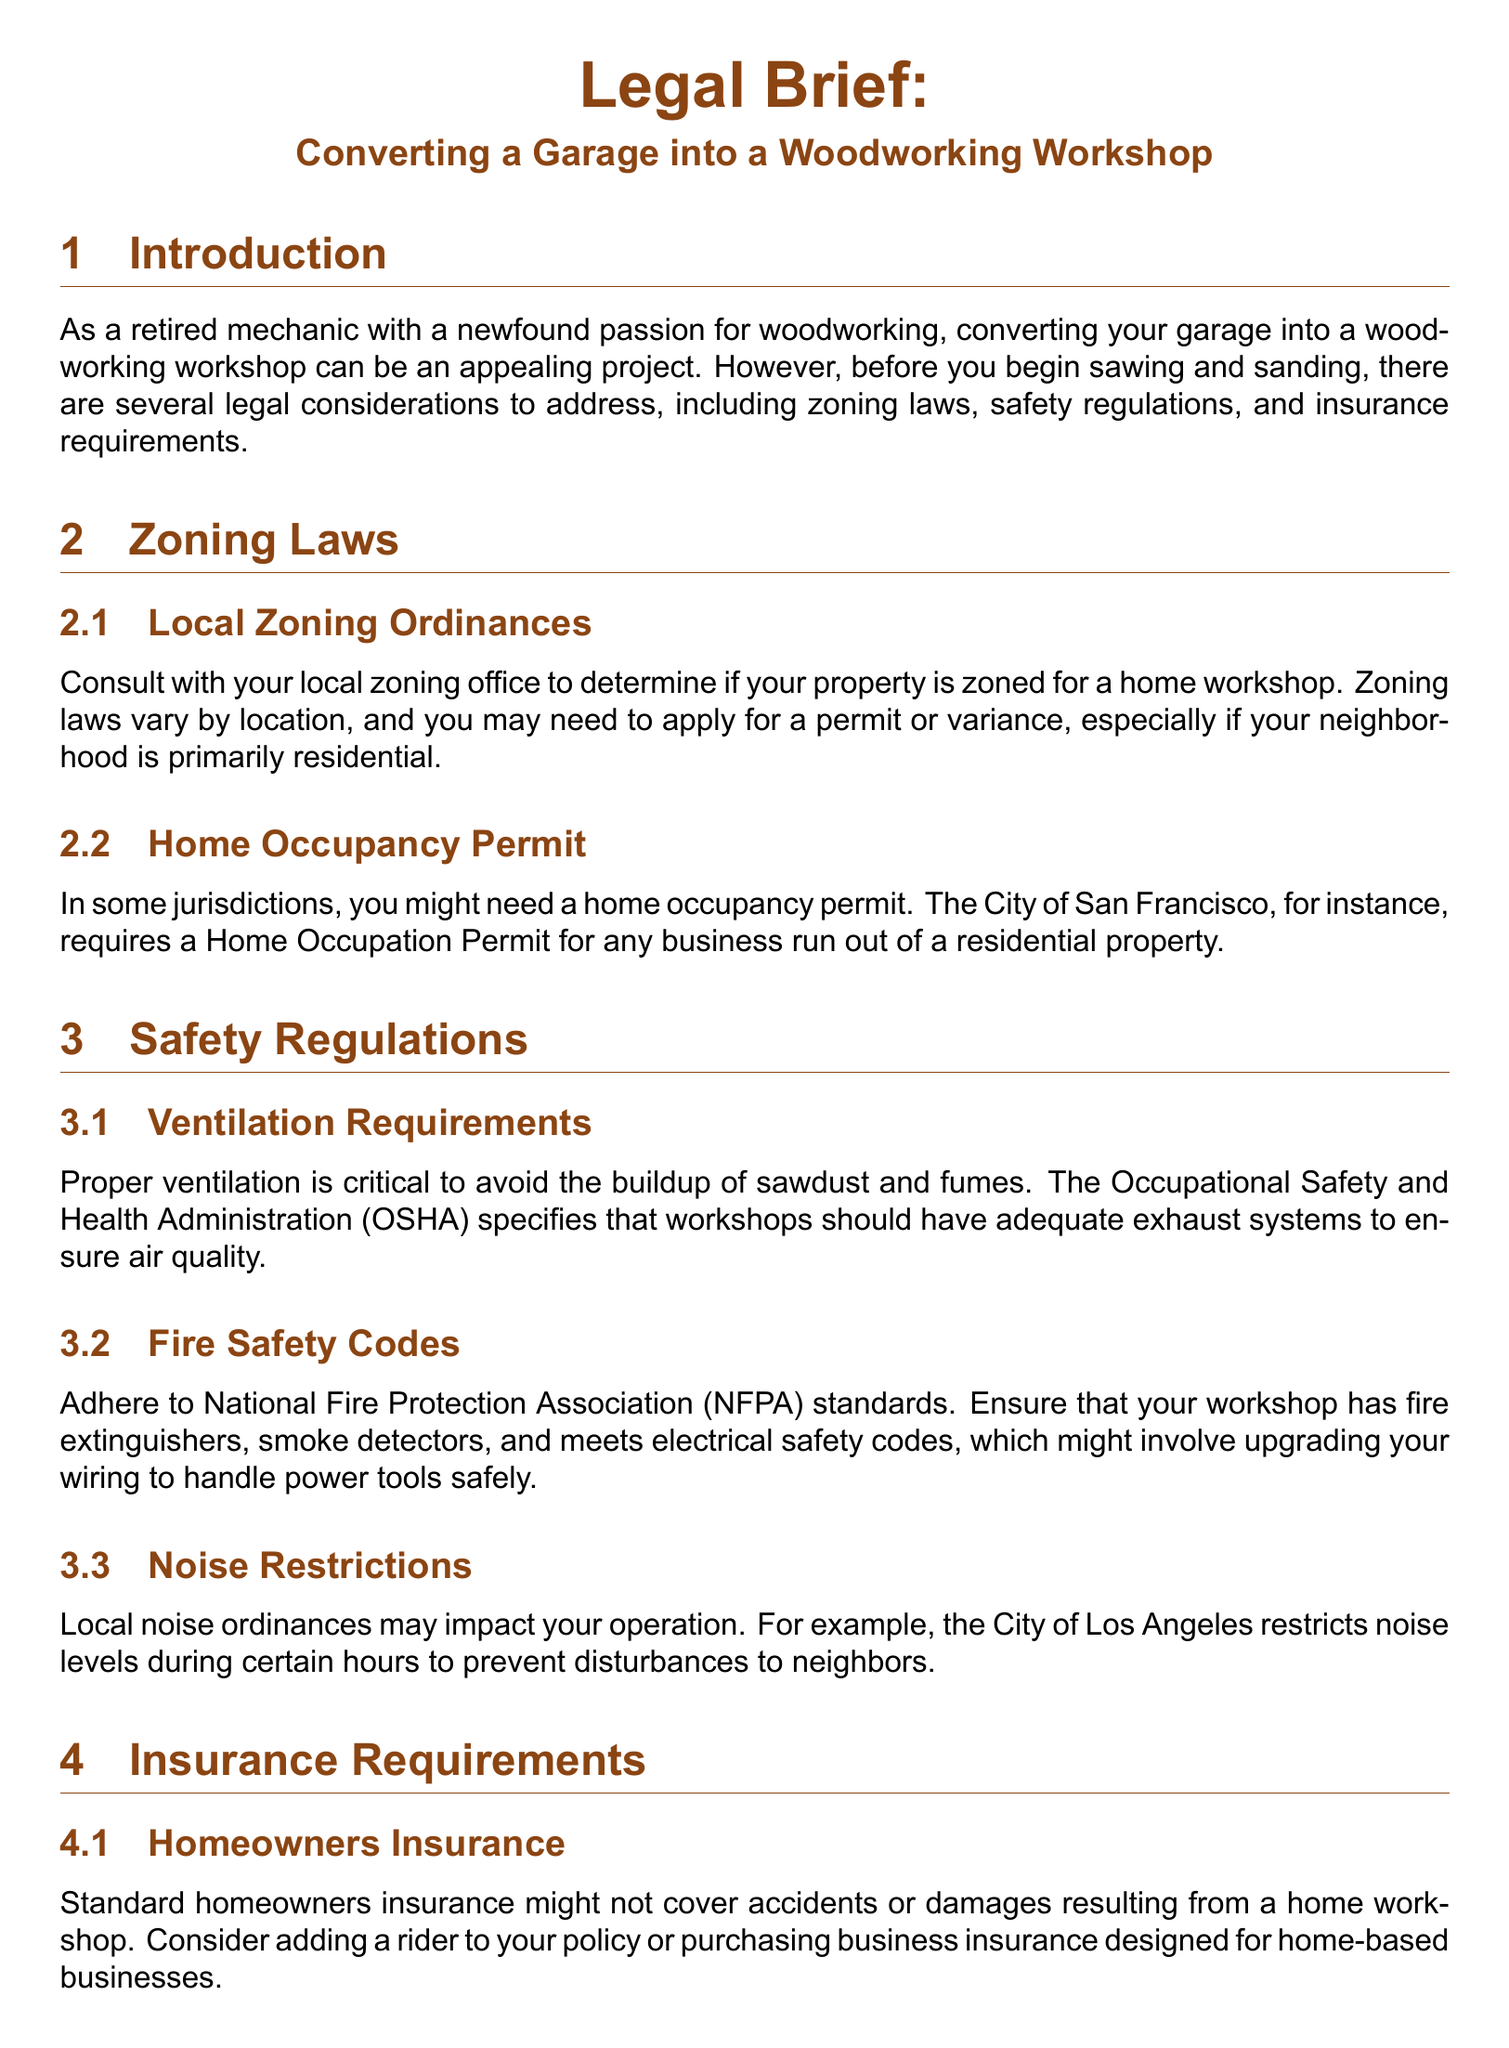What do you need to check with your local zoning office? You need to check if your property is zoned for a home workshop.
Answer: Zoning What permit might you need in some jurisdictions? You might need a home occupancy permit.
Answer: Home Occupancy Permit What organization specifies ventilation requirements for workshops? The Occupational Safety and Health Administration (OSHA) specifies ventilation requirements.
Answer: OSHA What is required for fire safety in your workshop? You need to ensure that your workshop has fire extinguishers, smoke detectors, and meets electrical safety codes.
Answer: Fire extinguishers What type of insurance should you consider for your workshop? Consider adding a rider to your homeowners insurance policy or purchasing business insurance.
Answer: Business insurance Which city restricts noise levels during certain hours? The City of Los Angeles restricts noise levels during certain hours.
Answer: City of Los Angeles What does liability insurance protect you from? Liability insurance protects you in case someone is injured on your property.
Answer: Injuries What is the main focus of the conclusion section? The main focus is on complying with legal considerations before converting your garage.
Answer: Legal considerations How many sections are in the document? There are five sections in the document.
Answer: Five 